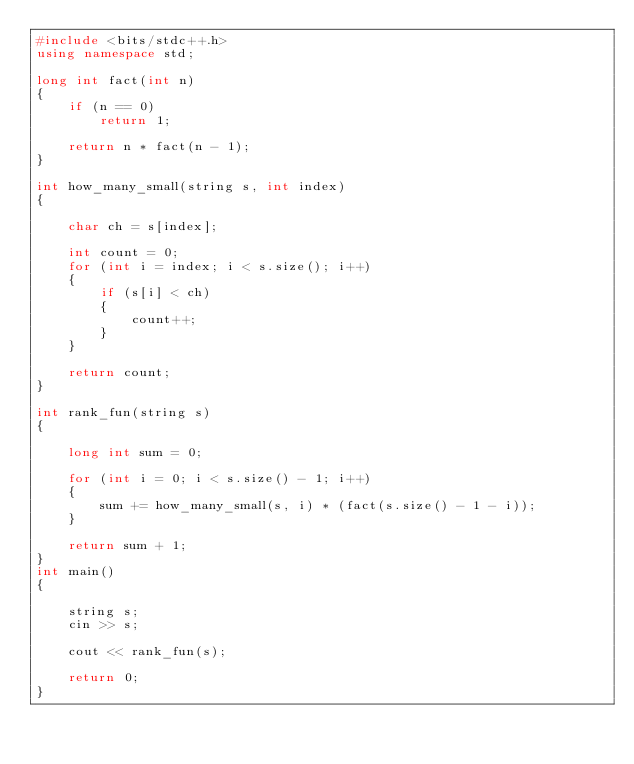<code> <loc_0><loc_0><loc_500><loc_500><_C++_>#include <bits/stdc++.h>
using namespace std;

long int fact(int n)
{
    if (n == 0)
        return 1;

    return n * fact(n - 1);
}

int how_many_small(string s, int index)
{

    char ch = s[index];

    int count = 0;
    for (int i = index; i < s.size(); i++)
    {
        if (s[i] < ch)
        {
            count++;
        }
    }

    return count;
}

int rank_fun(string s)
{

    long int sum = 0;

    for (int i = 0; i < s.size() - 1; i++)
    {
        sum += how_many_small(s, i) * (fact(s.size() - 1 - i));
    }

    return sum + 1;
}
int main()
{

    string s;
    cin >> s;

    cout << rank_fun(s);

    return 0;
}</code> 